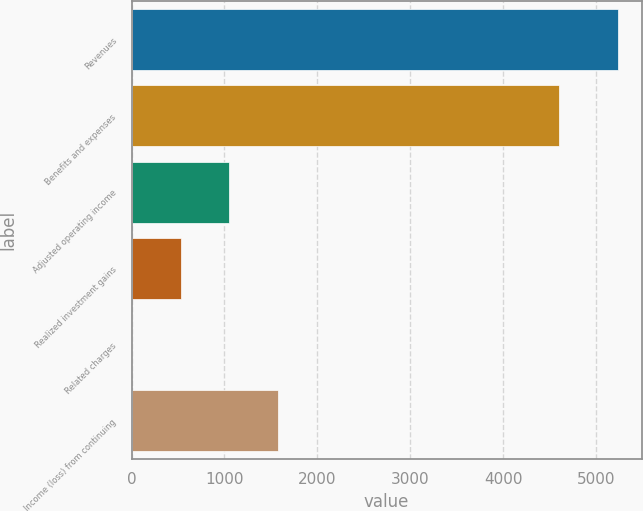Convert chart. <chart><loc_0><loc_0><loc_500><loc_500><bar_chart><fcel>Revenues<fcel>Benefits and expenses<fcel>Adjusted operating income<fcel>Realized investment gains<fcel>Related charges<fcel>Income (loss) from continuing<nl><fcel>5233<fcel>4598<fcel>1053.8<fcel>531.4<fcel>9<fcel>1576.2<nl></chart> 